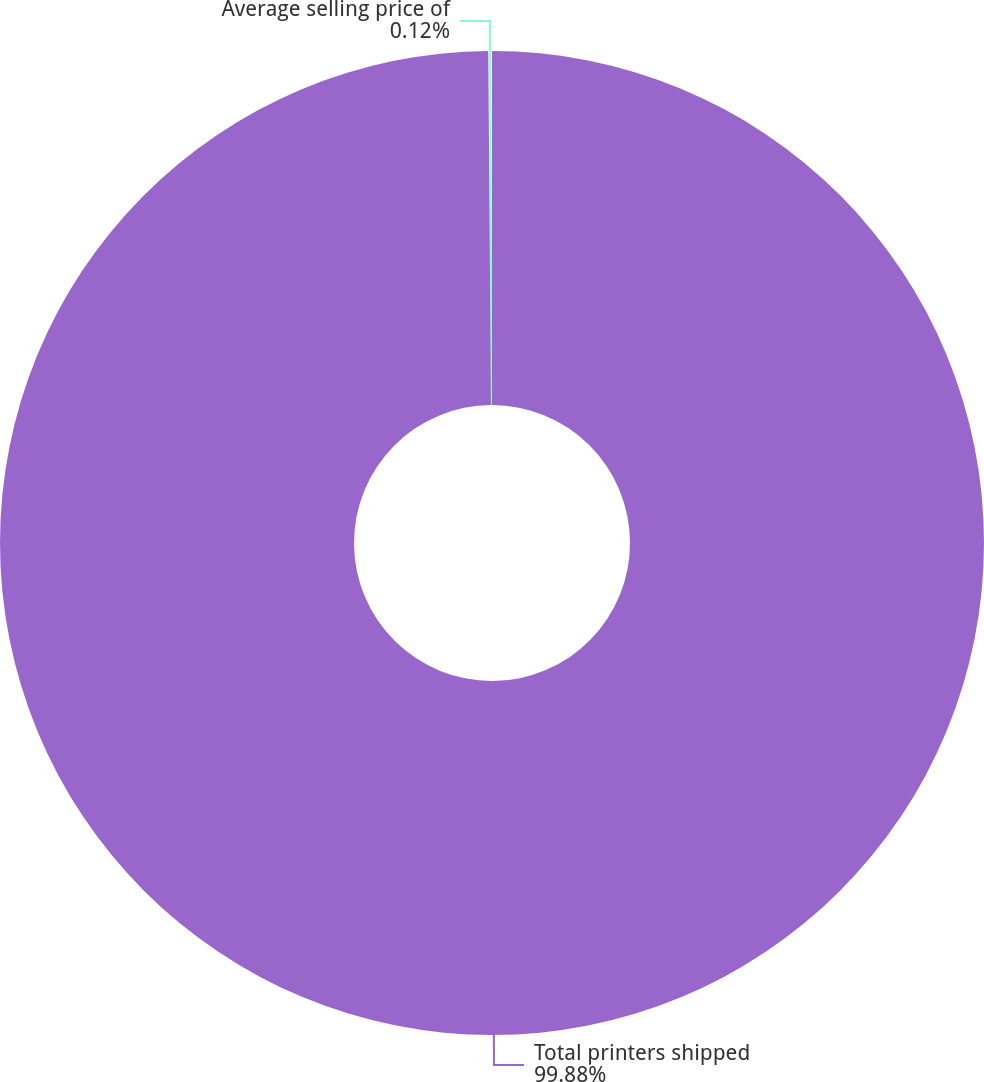Convert chart. <chart><loc_0><loc_0><loc_500><loc_500><pie_chart><fcel>Total printers shipped<fcel>Average selling price of<nl><fcel>99.88%<fcel>0.12%<nl></chart> 